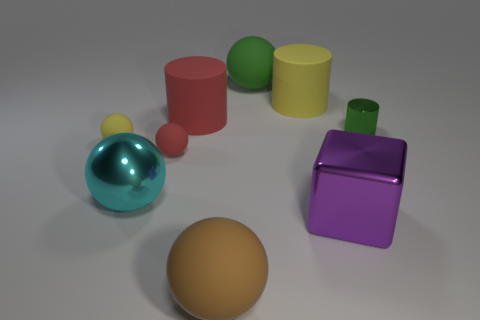There is a yellow object on the left side of the green thing behind the metal cylinder; how big is it? The yellow object appears to be a small cylinder, about one quarter the size of the green sphere adjacent to it. 